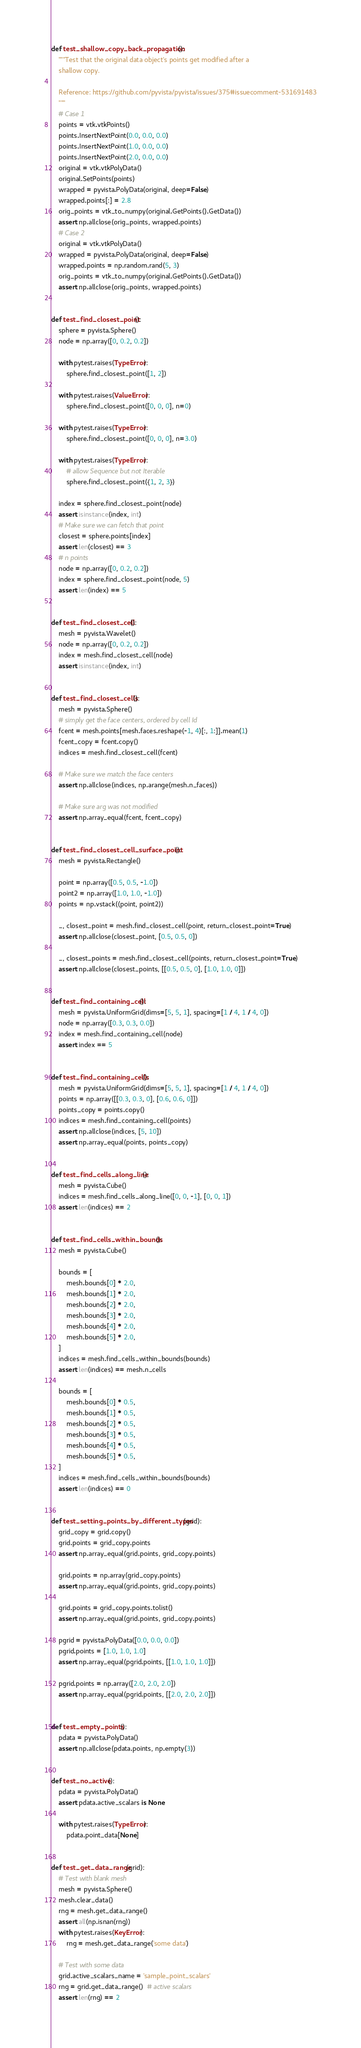<code> <loc_0><loc_0><loc_500><loc_500><_Python_>

def test_shallow_copy_back_propagation():
    """Test that the original data object's points get modified after a
    shallow copy.

    Reference: https://github.com/pyvista/pyvista/issues/375#issuecomment-531691483
    """
    # Case 1
    points = vtk.vtkPoints()
    points.InsertNextPoint(0.0, 0.0, 0.0)
    points.InsertNextPoint(1.0, 0.0, 0.0)
    points.InsertNextPoint(2.0, 0.0, 0.0)
    original = vtk.vtkPolyData()
    original.SetPoints(points)
    wrapped = pyvista.PolyData(original, deep=False)
    wrapped.points[:] = 2.8
    orig_points = vtk_to_numpy(original.GetPoints().GetData())
    assert np.allclose(orig_points, wrapped.points)
    # Case 2
    original = vtk.vtkPolyData()
    wrapped = pyvista.PolyData(original, deep=False)
    wrapped.points = np.random.rand(5, 3)
    orig_points = vtk_to_numpy(original.GetPoints().GetData())
    assert np.allclose(orig_points, wrapped.points)


def test_find_closest_point():
    sphere = pyvista.Sphere()
    node = np.array([0, 0.2, 0.2])

    with pytest.raises(TypeError):
        sphere.find_closest_point([1, 2])

    with pytest.raises(ValueError):
        sphere.find_closest_point([0, 0, 0], n=0)

    with pytest.raises(TypeError):
        sphere.find_closest_point([0, 0, 0], n=3.0)

    with pytest.raises(TypeError):
        # allow Sequence but not Iterable
        sphere.find_closest_point({1, 2, 3})

    index = sphere.find_closest_point(node)
    assert isinstance(index, int)
    # Make sure we can fetch that point
    closest = sphere.points[index]
    assert len(closest) == 3
    # n points
    node = np.array([0, 0.2, 0.2])
    index = sphere.find_closest_point(node, 5)
    assert len(index) == 5


def test_find_closest_cell():
    mesh = pyvista.Wavelet()
    node = np.array([0, 0.2, 0.2])
    index = mesh.find_closest_cell(node)
    assert isinstance(index, int)


def test_find_closest_cells():
    mesh = pyvista.Sphere()
    # simply get the face centers, ordered by cell Id
    fcent = mesh.points[mesh.faces.reshape(-1, 4)[:, 1:]].mean(1)
    fcent_copy = fcent.copy()
    indices = mesh.find_closest_cell(fcent)

    # Make sure we match the face centers
    assert np.allclose(indices, np.arange(mesh.n_faces))

    # Make sure arg was not modified
    assert np.array_equal(fcent, fcent_copy)


def test_find_closest_cell_surface_point():
    mesh = pyvista.Rectangle()

    point = np.array([0.5, 0.5, -1.0])
    point2 = np.array([1.0, 1.0, -1.0])
    points = np.vstack((point, point2))

    _, closest_point = mesh.find_closest_cell(point, return_closest_point=True)
    assert np.allclose(closest_point, [0.5, 0.5, 0])

    _, closest_points = mesh.find_closest_cell(points, return_closest_point=True)
    assert np.allclose(closest_points, [[0.5, 0.5, 0], [1.0, 1.0, 0]])


def test_find_containing_cell():
    mesh = pyvista.UniformGrid(dims=[5, 5, 1], spacing=[1 / 4, 1 / 4, 0])
    node = np.array([0.3, 0.3, 0.0])
    index = mesh.find_containing_cell(node)
    assert index == 5


def test_find_containing_cells():
    mesh = pyvista.UniformGrid(dims=[5, 5, 1], spacing=[1 / 4, 1 / 4, 0])
    points = np.array([[0.3, 0.3, 0], [0.6, 0.6, 0]])
    points_copy = points.copy()
    indices = mesh.find_containing_cell(points)
    assert np.allclose(indices, [5, 10])
    assert np.array_equal(points, points_copy)


def test_find_cells_along_line():
    mesh = pyvista.Cube()
    indices = mesh.find_cells_along_line([0, 0, -1], [0, 0, 1])
    assert len(indices) == 2


def test_find_cells_within_bounds():
    mesh = pyvista.Cube()

    bounds = [
        mesh.bounds[0] * 2.0,
        mesh.bounds[1] * 2.0,
        mesh.bounds[2] * 2.0,
        mesh.bounds[3] * 2.0,
        mesh.bounds[4] * 2.0,
        mesh.bounds[5] * 2.0,
    ]
    indices = mesh.find_cells_within_bounds(bounds)
    assert len(indices) == mesh.n_cells

    bounds = [
        mesh.bounds[0] * 0.5,
        mesh.bounds[1] * 0.5,
        mesh.bounds[2] * 0.5,
        mesh.bounds[3] * 0.5,
        mesh.bounds[4] * 0.5,
        mesh.bounds[5] * 0.5,
    ]
    indices = mesh.find_cells_within_bounds(bounds)
    assert len(indices) == 0


def test_setting_points_by_different_types(grid):
    grid_copy = grid.copy()
    grid.points = grid_copy.points
    assert np.array_equal(grid.points, grid_copy.points)

    grid.points = np.array(grid_copy.points)
    assert np.array_equal(grid.points, grid_copy.points)

    grid.points = grid_copy.points.tolist()
    assert np.array_equal(grid.points, grid_copy.points)

    pgrid = pyvista.PolyData([0.0, 0.0, 0.0])
    pgrid.points = [1.0, 1.0, 1.0]
    assert np.array_equal(pgrid.points, [[1.0, 1.0, 1.0]])

    pgrid.points = np.array([2.0, 2.0, 2.0])
    assert np.array_equal(pgrid.points, [[2.0, 2.0, 2.0]])


def test_empty_points():
    pdata = pyvista.PolyData()
    assert np.allclose(pdata.points, np.empty(3))


def test_no_active():
    pdata = pyvista.PolyData()
    assert pdata.active_scalars is None

    with pytest.raises(TypeError):
        pdata.point_data[None]


def test_get_data_range(grid):
    # Test with blank mesh
    mesh = pyvista.Sphere()
    mesh.clear_data()
    rng = mesh.get_data_range()
    assert all(np.isnan(rng))
    with pytest.raises(KeyError):
        rng = mesh.get_data_range('some data')

    # Test with some data
    grid.active_scalars_name = 'sample_point_scalars'
    rng = grid.get_data_range()  # active scalars
    assert len(rng) == 2</code> 